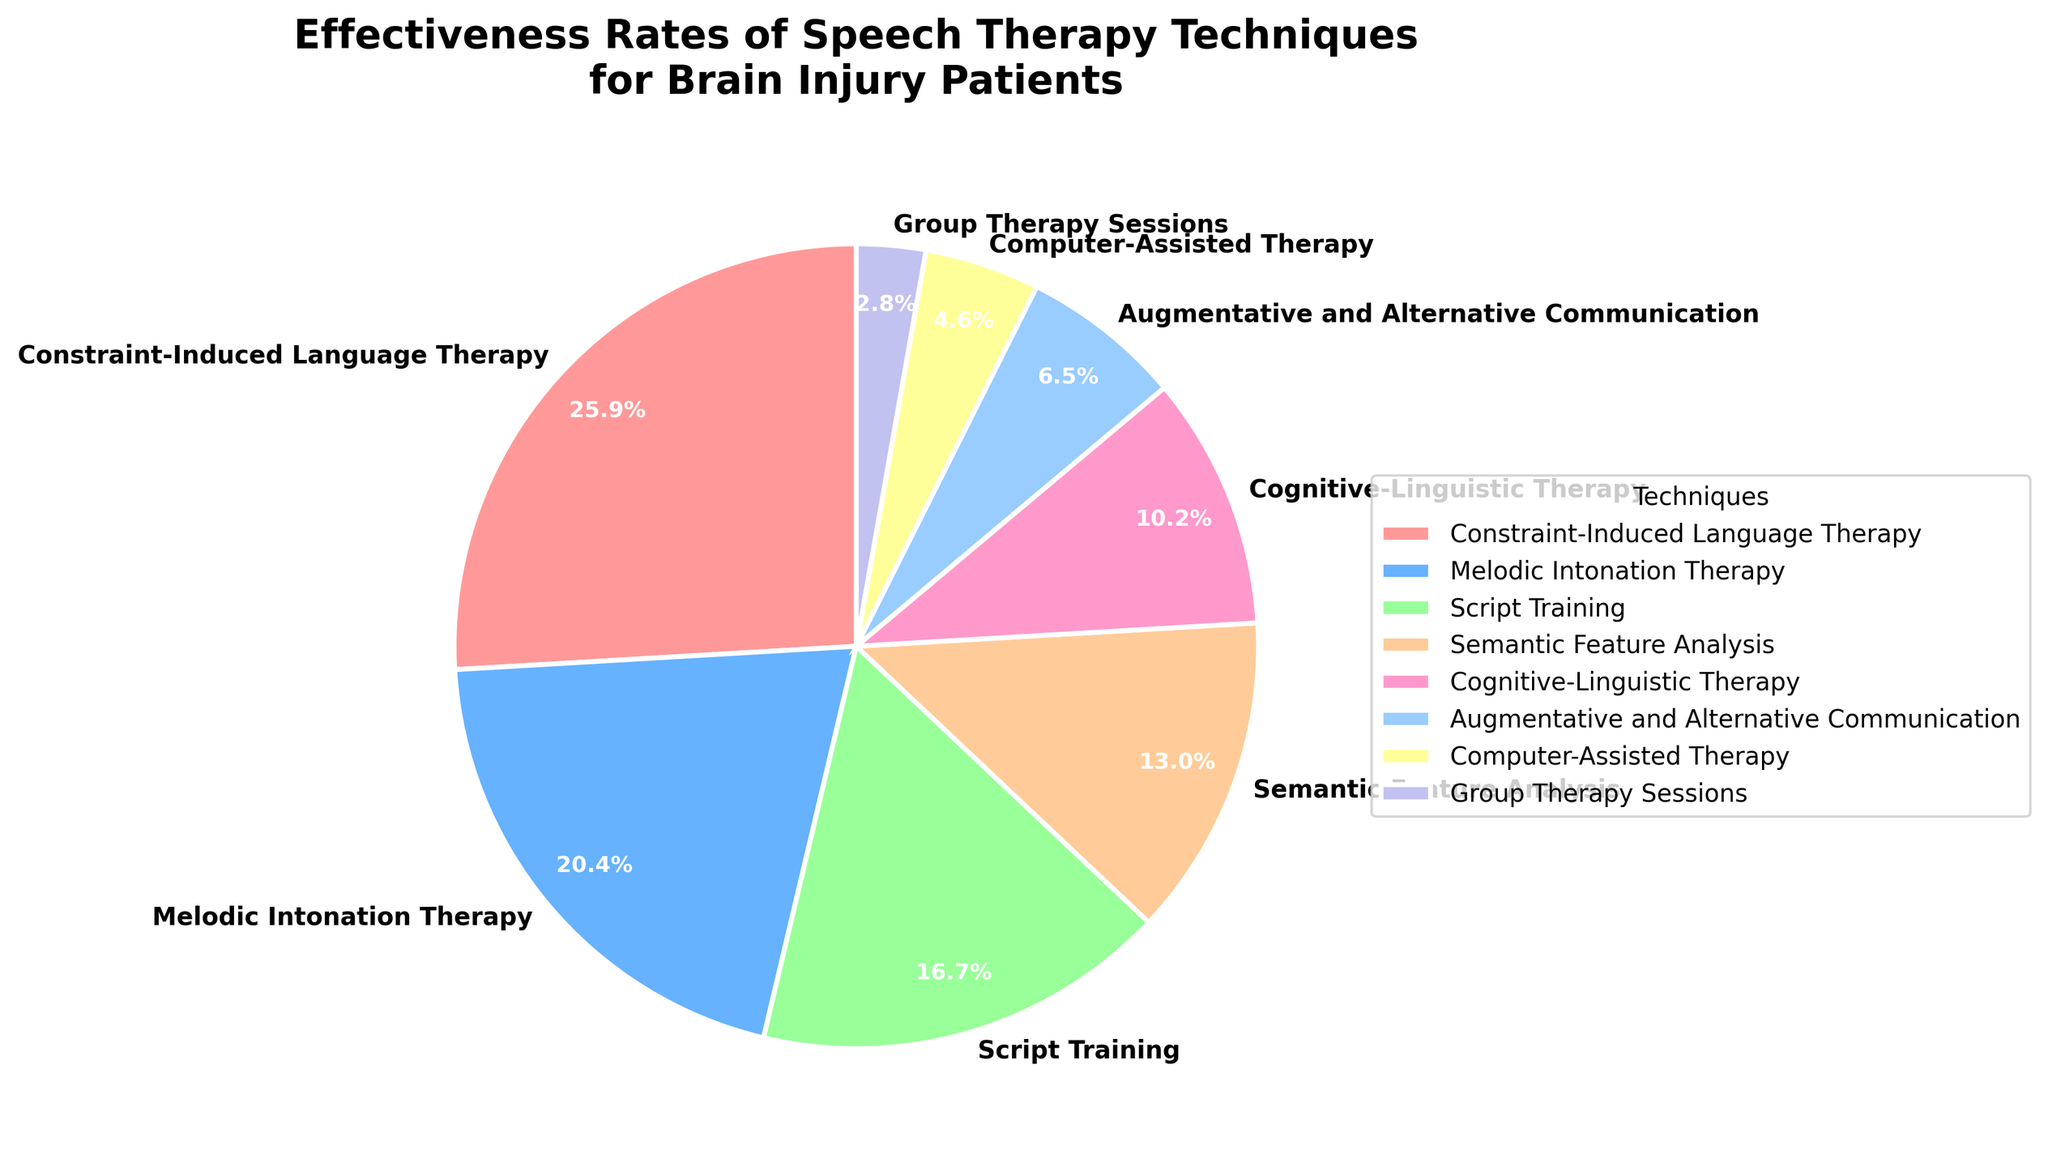What is the most effective speech therapy technique according to the pie chart? Look at the pie chart and identify the technique with the largest wedge. "Constraint-Induced Language Therapy" has the highest effectiveness rate, which is 28%.
Answer: Constraint-Induced Language Therapy Which two techniques have effectiveness rates that add up to 40%? Identify the techniques with their respective effectiveness rates. "Melodic Intonation Therapy" (22%) combined with "Script Training" (18%) adds up to 40% as 22 + 18 = 40.
Answer: Melodic Intonation Therapy and Script Training How does the effectiveness rate of "Semantic Feature Analysis" compare to "Cognitive-Linguistic Therapy"? Find the effectiveness rates of the two techniques. "Semantic Feature Analysis" has 14%, and "Cognitive-Linguistic Therapy" has 11%. Compare the two values and notice that 14% is greater than 11%.
Answer: Semantic Feature Analysis is more effective than Cognitive-Linguistic Therapy What percentage of the total effectiveness does "Augmentative and Alternative Communication" contribute? Identify the wedge corresponding to "Augmentative and Alternative Communication." Its effectiveness rate is 7%. The chart gives it as a percentage directly, so the answer is 7%.
Answer: 7% Which color is used to represent "Script Training" in the pie chart? Observe the pie chart and identify the color corresponding to "Script Training." Notice that it is represented by the color green.
Answer: Green What is the combined effectiveness rate of the three least effective techniques? Identify the least effective techniques: "Group Therapy Sessions" (3%), "Computer-Assisted Therapy" (5%), and "Augmentative and Alternative Communication" (7%). Sum their effectiveness rates: 3 + 5 + 7 = 15%.
Answer: 15% If you were to recommend a technique based on the top three most effective therapies, what would those be? Look at the top three largest wedges. They are "Constraint-Induced Language Therapy" (28%), "Melodic Intonation Therapy" (22%), and "Script Training" (18%).
Answer: Constraint-Induced Language Therapy, Melodic Intonation Therapy, Script Training How does the effectiveness rate of "Melodic Intonation Therapy" compare to the combined effectiveness rate of "Computer-Assisted Therapy" and "Group Therapy Sessions"? Compare "Melodic Intonation Therapy" (22%) with the sum of "Computer-Assisted Therapy" (5%) and "Group Therapy Sessions" (3%): 5 + 3 = 8%. Notice 22% is greater than 8%.
Answer: Melodic Intonation Therapy is more effective What is the ratio of the effectiveness rate of "Constraint-Induced Language Therapy" to "Cognitive-Linguistic Therapy"? Find the effectiveness rates: "Constraint-Induced Language Therapy" is 28%, and "Cognitive-Linguistic Therapy" is 11%. The ratio is 28:11.
Answer: 28:11 Which technique has the smallest wedge in the pie chart and what is its effectiveness rate? Identify the smallest wedge by looking at the pie chart, which corresponds to "Group Therapy Sessions." Its effectiveness rate is 3%.
Answer: Group Therapy Sessions, 3% 